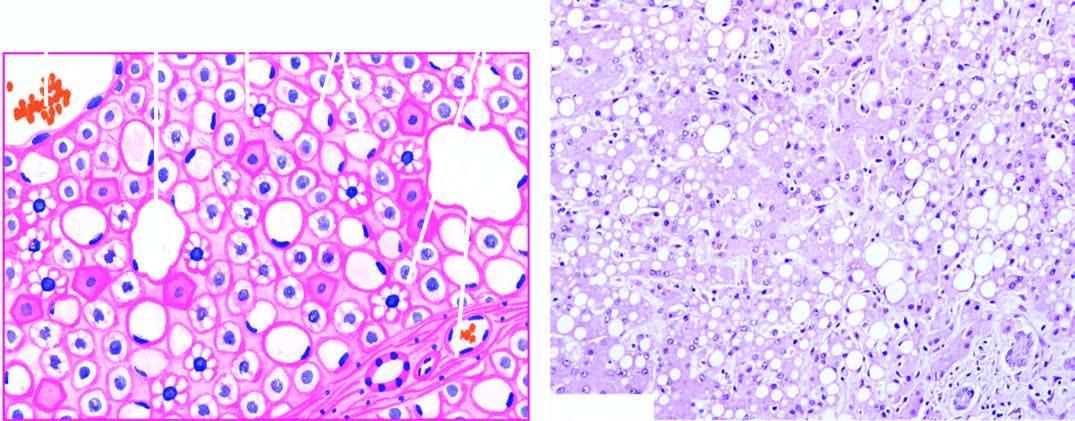re a few areas distended with large lipid vacuoles with peripherally displaced nuclei?
Answer the question using a single word or phrase. No 